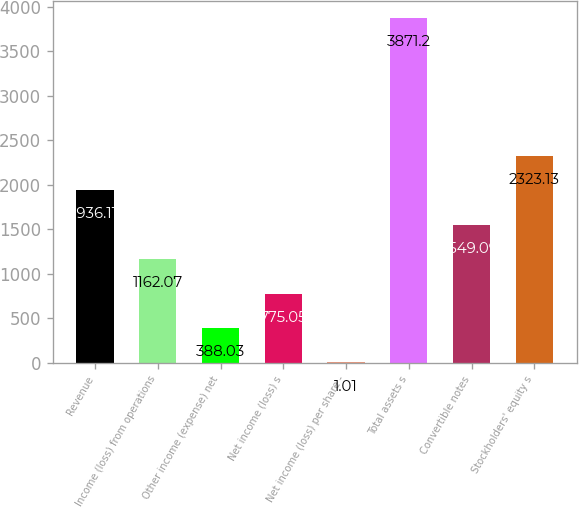Convert chart to OTSL. <chart><loc_0><loc_0><loc_500><loc_500><bar_chart><fcel>Revenue<fcel>Income (loss) from operations<fcel>Other income (expense) net<fcel>Net income (loss) s<fcel>Net income (loss) per share -<fcel>Total assets s<fcel>Convertible notes<fcel>Stockholders' equity s<nl><fcel>1936.11<fcel>1162.07<fcel>388.03<fcel>775.05<fcel>1.01<fcel>3871.2<fcel>1549.09<fcel>2323.13<nl></chart> 